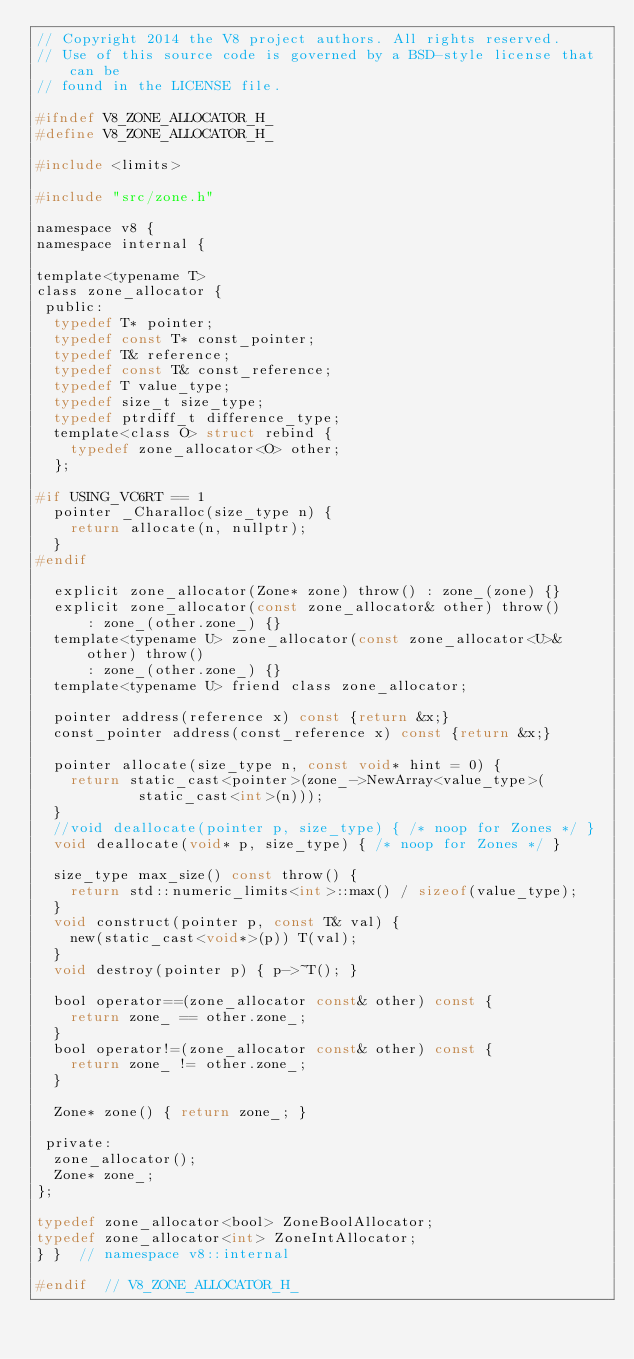Convert code to text. <code><loc_0><loc_0><loc_500><loc_500><_C_>// Copyright 2014 the V8 project authors. All rights reserved.
// Use of this source code is governed by a BSD-style license that can be
// found in the LICENSE file.

#ifndef V8_ZONE_ALLOCATOR_H_
#define V8_ZONE_ALLOCATOR_H_

#include <limits>

#include "src/zone.h"

namespace v8 {
namespace internal {

template<typename T>
class zone_allocator {
 public:
  typedef T* pointer;
  typedef const T* const_pointer;
  typedef T& reference;
  typedef const T& const_reference;
  typedef T value_type;
  typedef size_t size_type;
  typedef ptrdiff_t difference_type;
  template<class O> struct rebind {
    typedef zone_allocator<O> other;
  };

#if USING_VC6RT == 1
  pointer _Charalloc(size_type n) {
    return allocate(n, nullptr);
  }
#endif

  explicit zone_allocator(Zone* zone) throw() : zone_(zone) {}
  explicit zone_allocator(const zone_allocator& other) throw()
      : zone_(other.zone_) {}
  template<typename U> zone_allocator(const zone_allocator<U>& other) throw()
      : zone_(other.zone_) {}
  template<typename U> friend class zone_allocator;

  pointer address(reference x) const {return &x;}
  const_pointer address(const_reference x) const {return &x;}

  pointer allocate(size_type n, const void* hint = 0) {
    return static_cast<pointer>(zone_->NewArray<value_type>(
            static_cast<int>(n)));
  }
  //void deallocate(pointer p, size_type) { /* noop for Zones */ }
  void deallocate(void* p, size_type) { /* noop for Zones */ }

  size_type max_size() const throw() {
    return std::numeric_limits<int>::max() / sizeof(value_type);
  }
  void construct(pointer p, const T& val) {
    new(static_cast<void*>(p)) T(val);
  }
  void destroy(pointer p) { p->~T(); }

  bool operator==(zone_allocator const& other) const {
    return zone_ == other.zone_;
  }
  bool operator!=(zone_allocator const& other) const {
    return zone_ != other.zone_;
  }

  Zone* zone() { return zone_; }

 private:
  zone_allocator();
  Zone* zone_;
};

typedef zone_allocator<bool> ZoneBoolAllocator;
typedef zone_allocator<int> ZoneIntAllocator;
} }  // namespace v8::internal

#endif  // V8_ZONE_ALLOCATOR_H_
</code> 